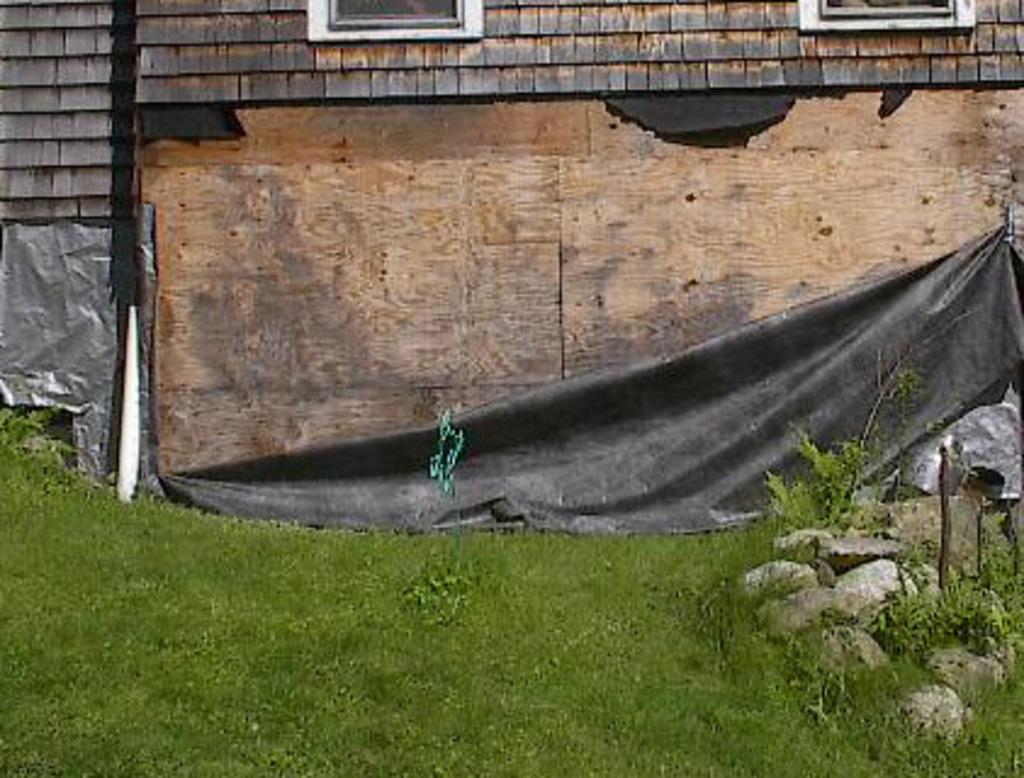In one or two sentences, can you explain what this image depicts? In this image I can see the grass. On the right side, I can see the stones. In the background, I can see the wall. 